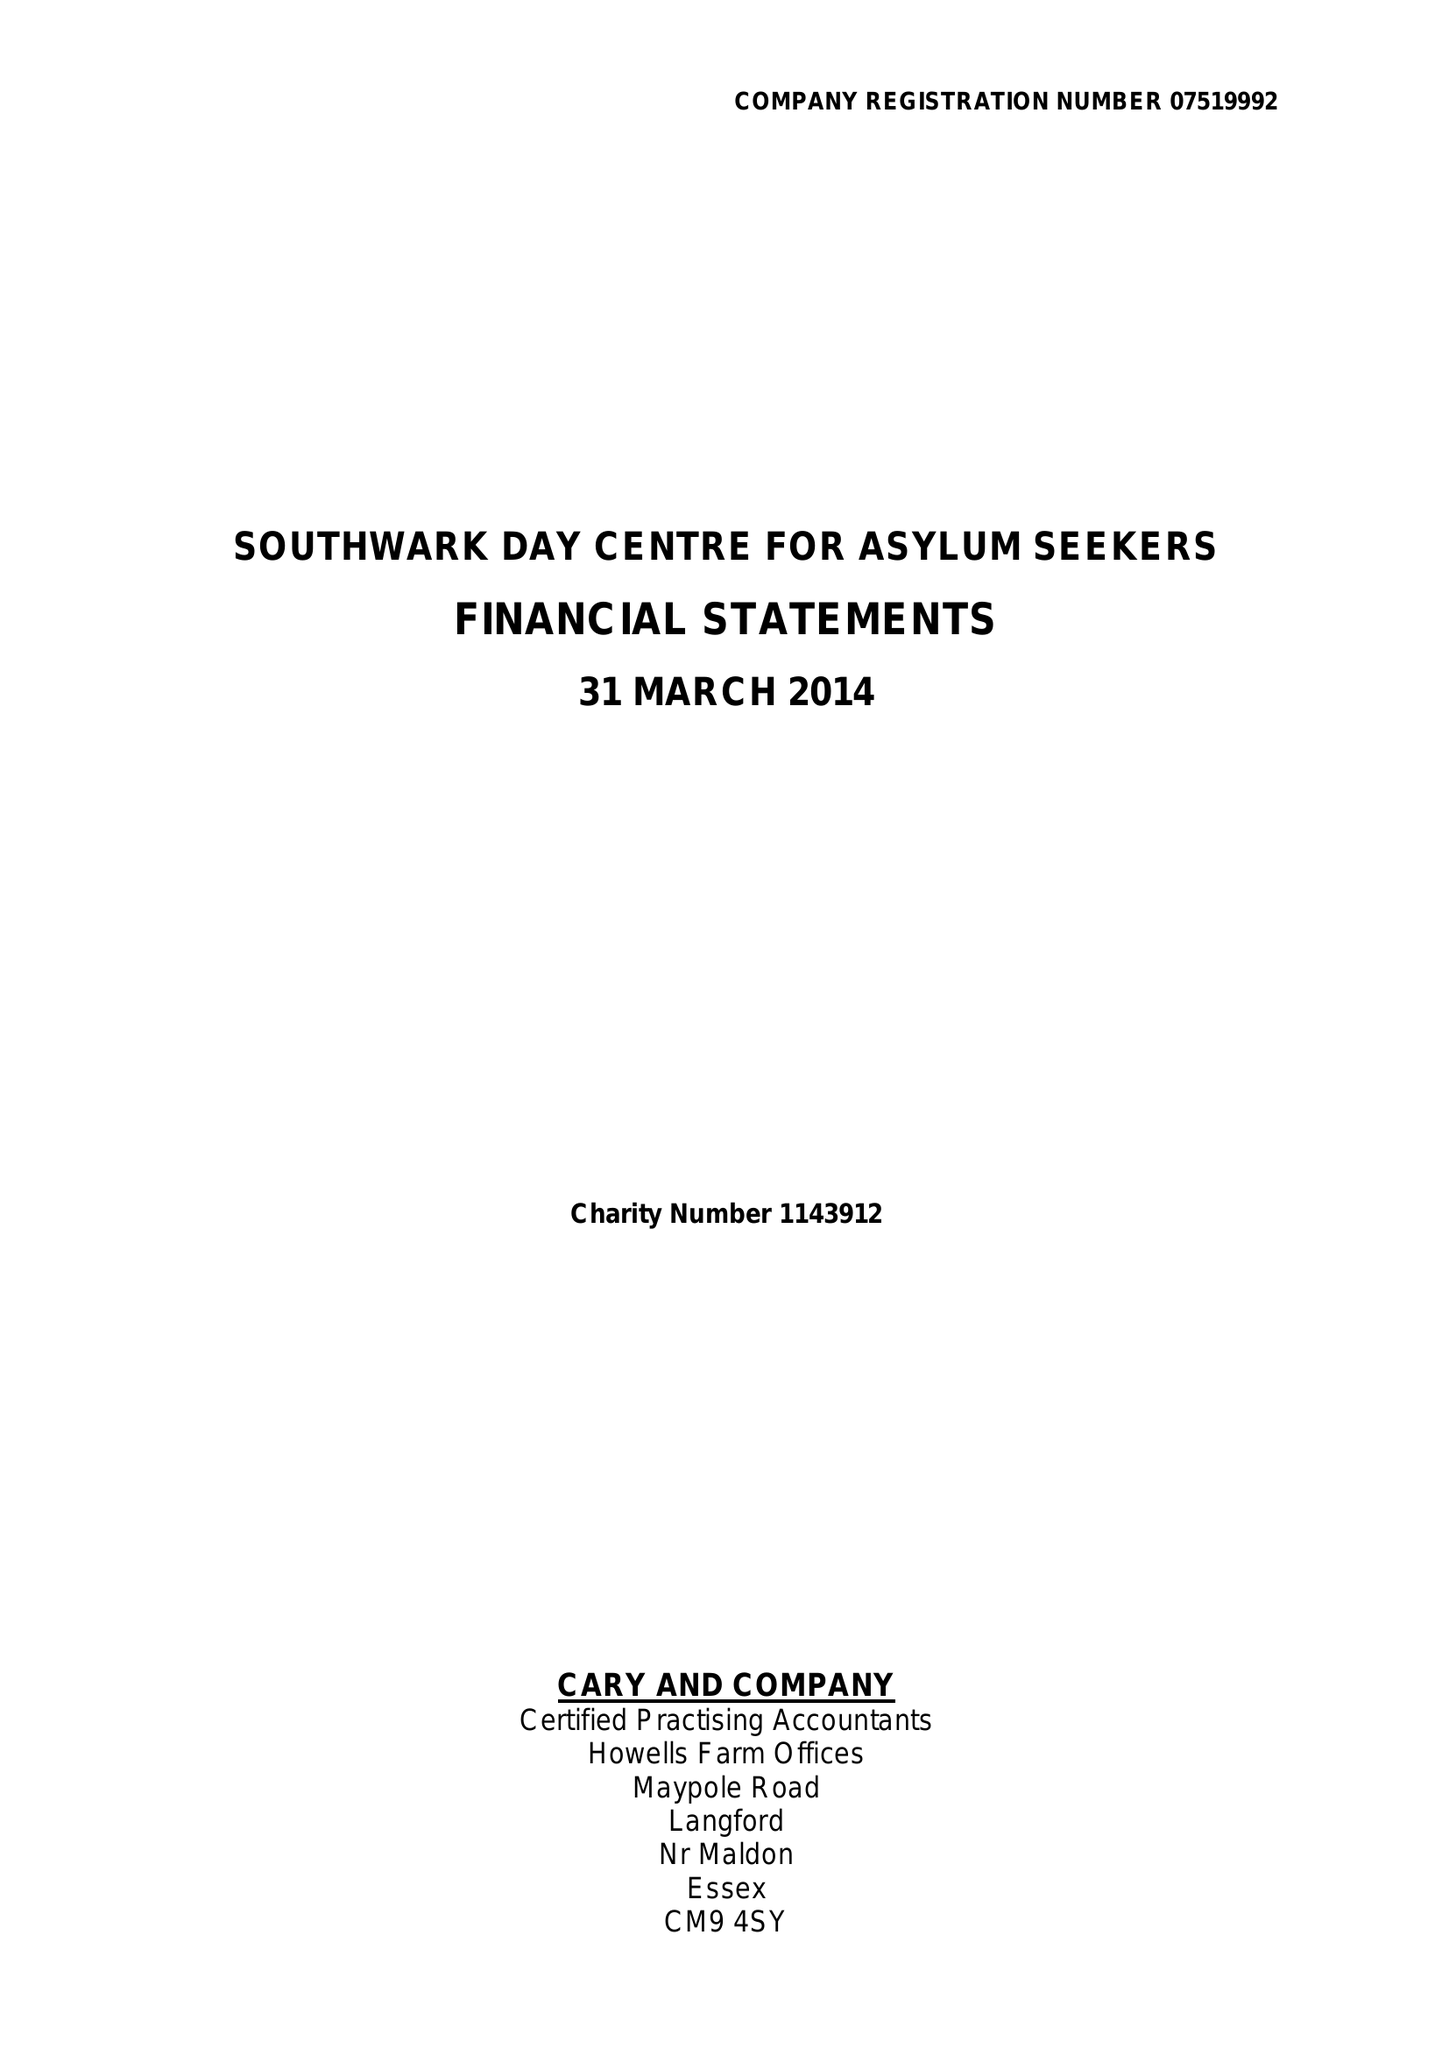What is the value for the charity_name?
Answer the question using a single word or phrase. Southwark Day Centre For Asylum Seekers 